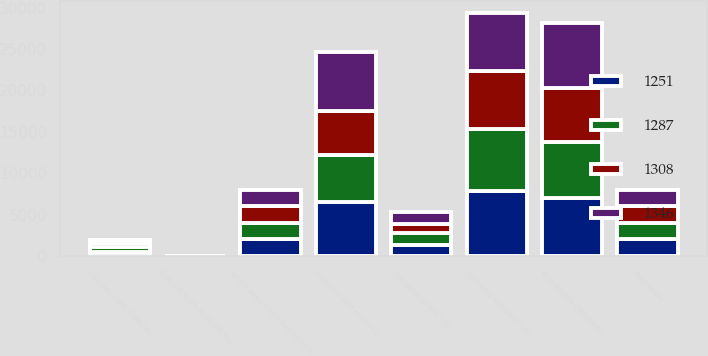<chart> <loc_0><loc_0><loc_500><loc_500><stacked_bar_chart><ecel><fcel>For the years ended December31<fcel>Operating revenues ^(a)<fcel>Operating income^(a)<fcel>Common stock dividends<fcel>Common stock dividends per<fcel>Total assets<fcel>Long-term debt excluding<fcel>Total Ameren Corporation<nl><fcel>1346<fcel>2009<fcel>7090<fcel>1416<fcel>338<fcel>1.54<fcel>2007.5<fcel>7113<fcel>7853<nl><fcel>1251<fcel>2008<fcel>7839<fcel>1362<fcel>534<fcel>2.54<fcel>2007.5<fcel>6554<fcel>6963<nl><fcel>1287<fcel>2007<fcel>7562<fcel>1359<fcel>527<fcel>2.54<fcel>2007.5<fcel>5689<fcel>6752<nl><fcel>1308<fcel>2006<fcel>6895<fcel>1188<fcel>522<fcel>2.54<fcel>2007.5<fcel>5285<fcel>6583<nl></chart> 